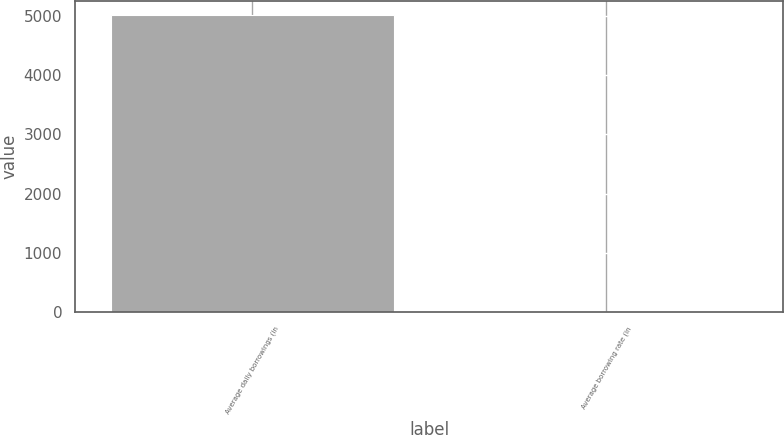Convert chart to OTSL. <chart><loc_0><loc_0><loc_500><loc_500><bar_chart><fcel>Average daily borrowings (in<fcel>Average borrowing rate (in<nl><fcel>5005<fcel>6.7<nl></chart> 